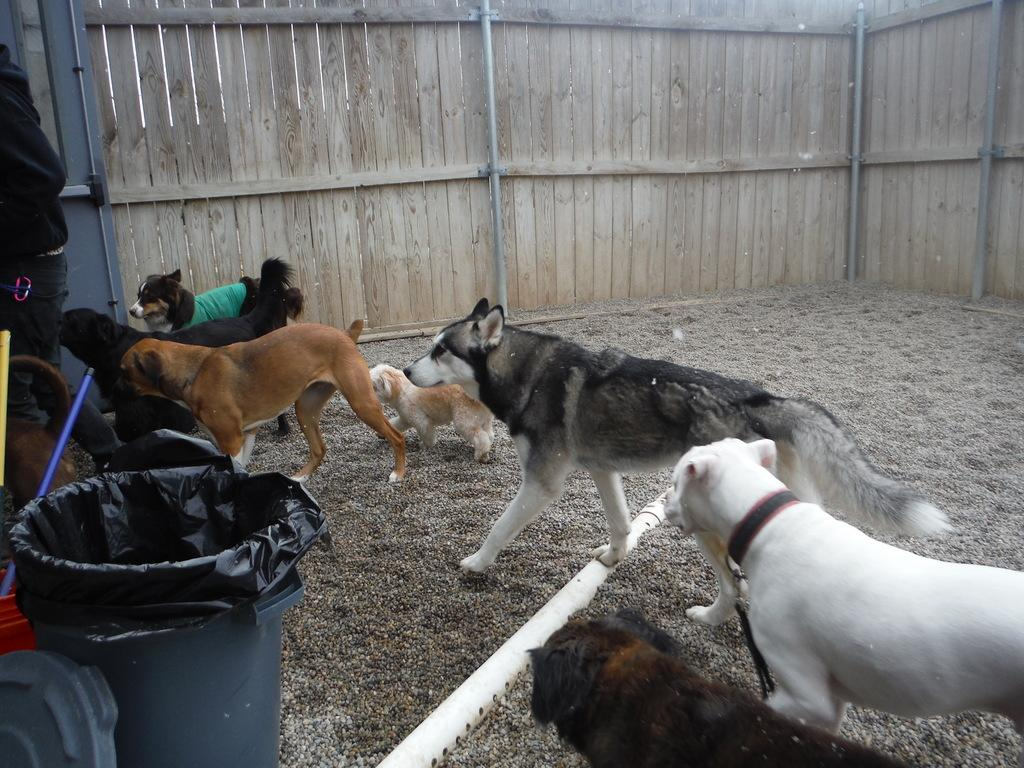What type of animals can be seen in the image? There are dogs in the image. What object is present for waste disposal? There is a dustbin in the image. What is the color of the rod in the image? The rod in the image is white. Can you describe the person in the image? There is a person in the image. What type of fencing is visible at the top of the image? There is wooden fencing at the top of the image. How many brothers does the person in the image have? There is no information about the person's brothers in the image. What type of growth can be seen on the dogs in the image? There is no growth visible on the dogs in the image. 